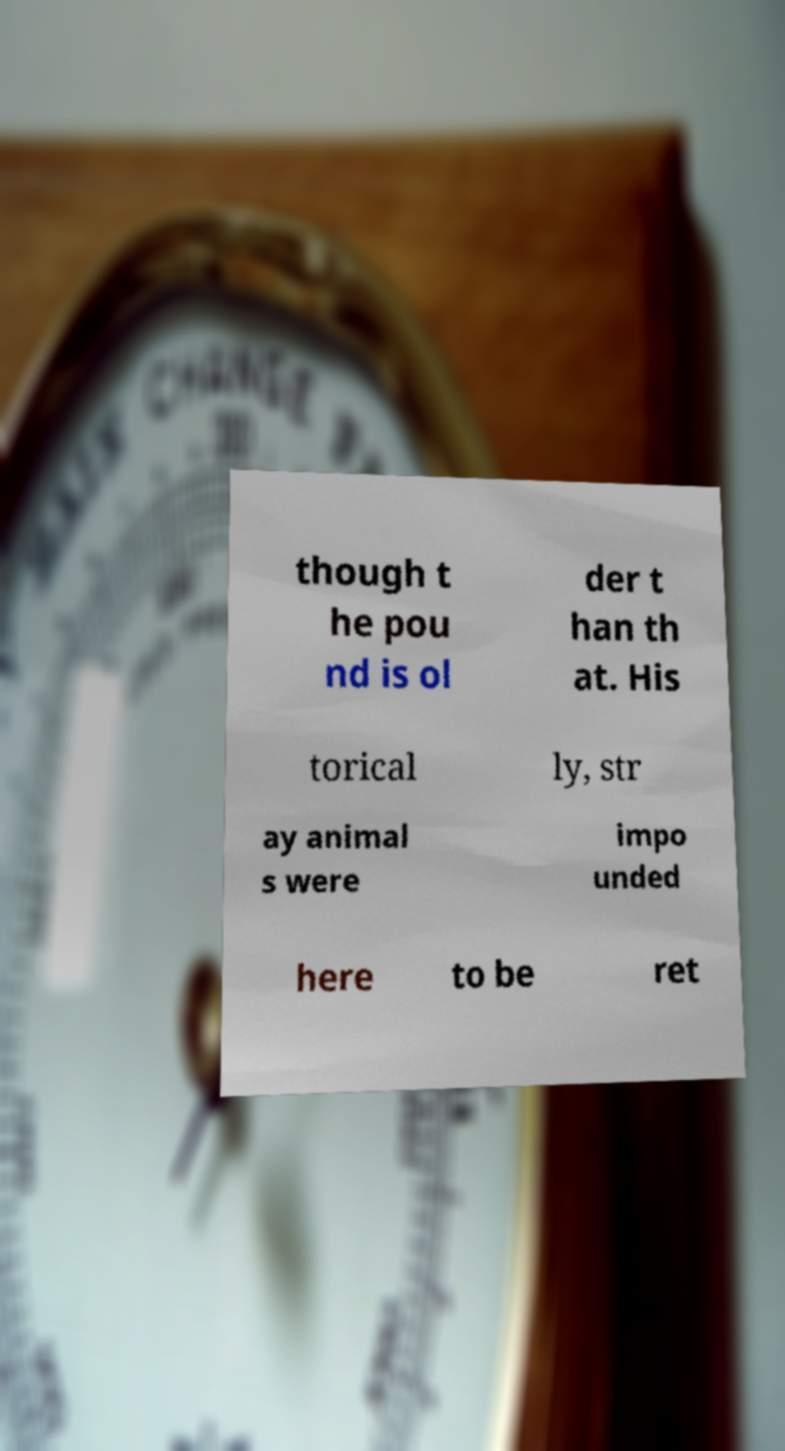For documentation purposes, I need the text within this image transcribed. Could you provide that? though t he pou nd is ol der t han th at. His torical ly, str ay animal s were impo unded here to be ret 